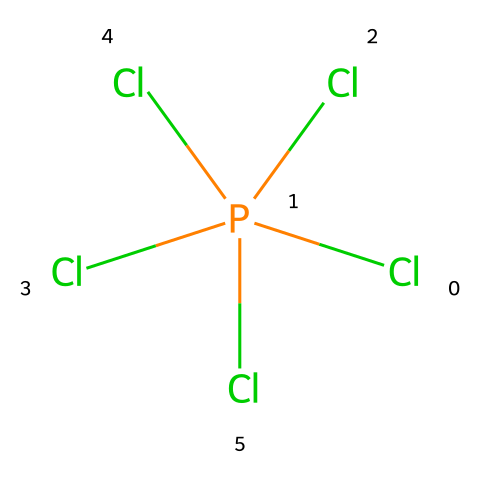How many chlorine atoms are present in this molecule? The provided SMILES indicates the structure "Cl[P@](Cl)(Cl)(Cl)Cl", which shows that there are five chlorine atoms bonded to the phosphorus atom. Each "Cl" represents one chlorine atom.
Answer: five What is the central atom in this structure? The structure shows that the phosphorus atom, represented by "P", is at the center of the compound, bonded to multiple chlorine atoms.
Answer: phosphorus How many total bonds are formed in this compound? In the SMILES notation, phosphorus is bonded to five chlorine atoms, representing five single bonds. There are also five lines of connectivity indicating that these bonds are present.
Answer: five What type of hybridization does phosphorus exhibit in this compound? Phosphorus in phosphorus pentachloride typically assumes an sp3d hybridization to accommodate five substituents, indicating the presence of four single bonds and one lone pair in a trigonal bipyramidal arrangement.
Answer: sp3d What is the geometry of phosphorus pentachloride? Given the bonding arrangement of five chlorine atoms around a phosphorus atom, phosphorus pentachloride adopts a trigonal bipyramidal geometry which minimizes electron pair repulsion.
Answer: trigonal bipyramidal Is phosphorus pentachloride a hypervalent compound? The presence of more than eight electrons around the phosphorus atom, due to five chlorine bonds plus any lone pairs on phosphorus, confirms that it is classified as a hypervalent compound.
Answer: yes 